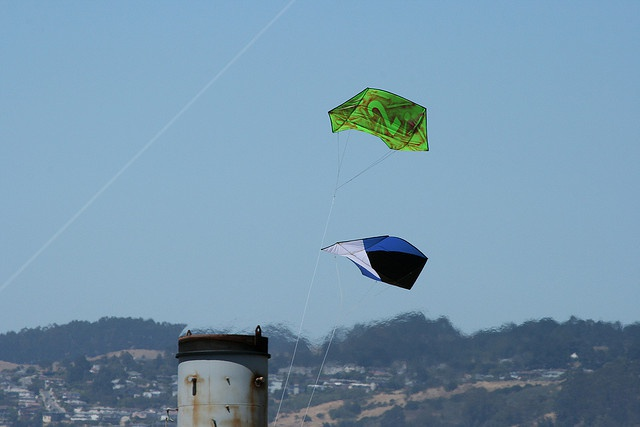Describe the objects in this image and their specific colors. I can see kite in lightblue, darkgreen, green, and black tones and kite in lightblue, black, darkgray, and blue tones in this image. 